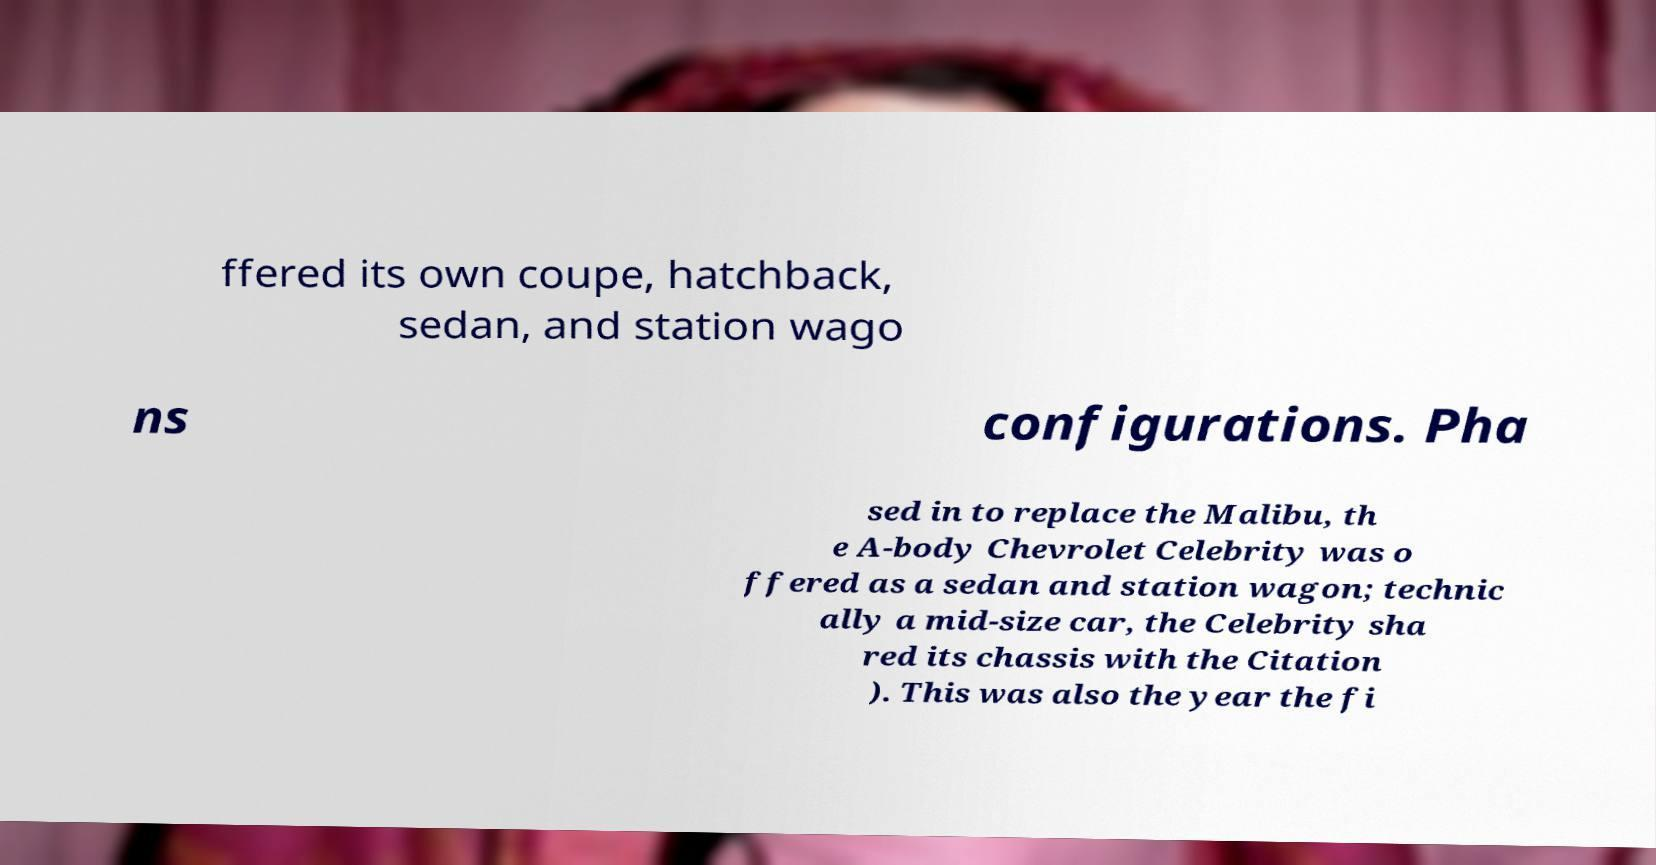For documentation purposes, I need the text within this image transcribed. Could you provide that? ffered its own coupe, hatchback, sedan, and station wago ns configurations. Pha sed in to replace the Malibu, th e A-body Chevrolet Celebrity was o ffered as a sedan and station wagon; technic ally a mid-size car, the Celebrity sha red its chassis with the Citation ). This was also the year the fi 